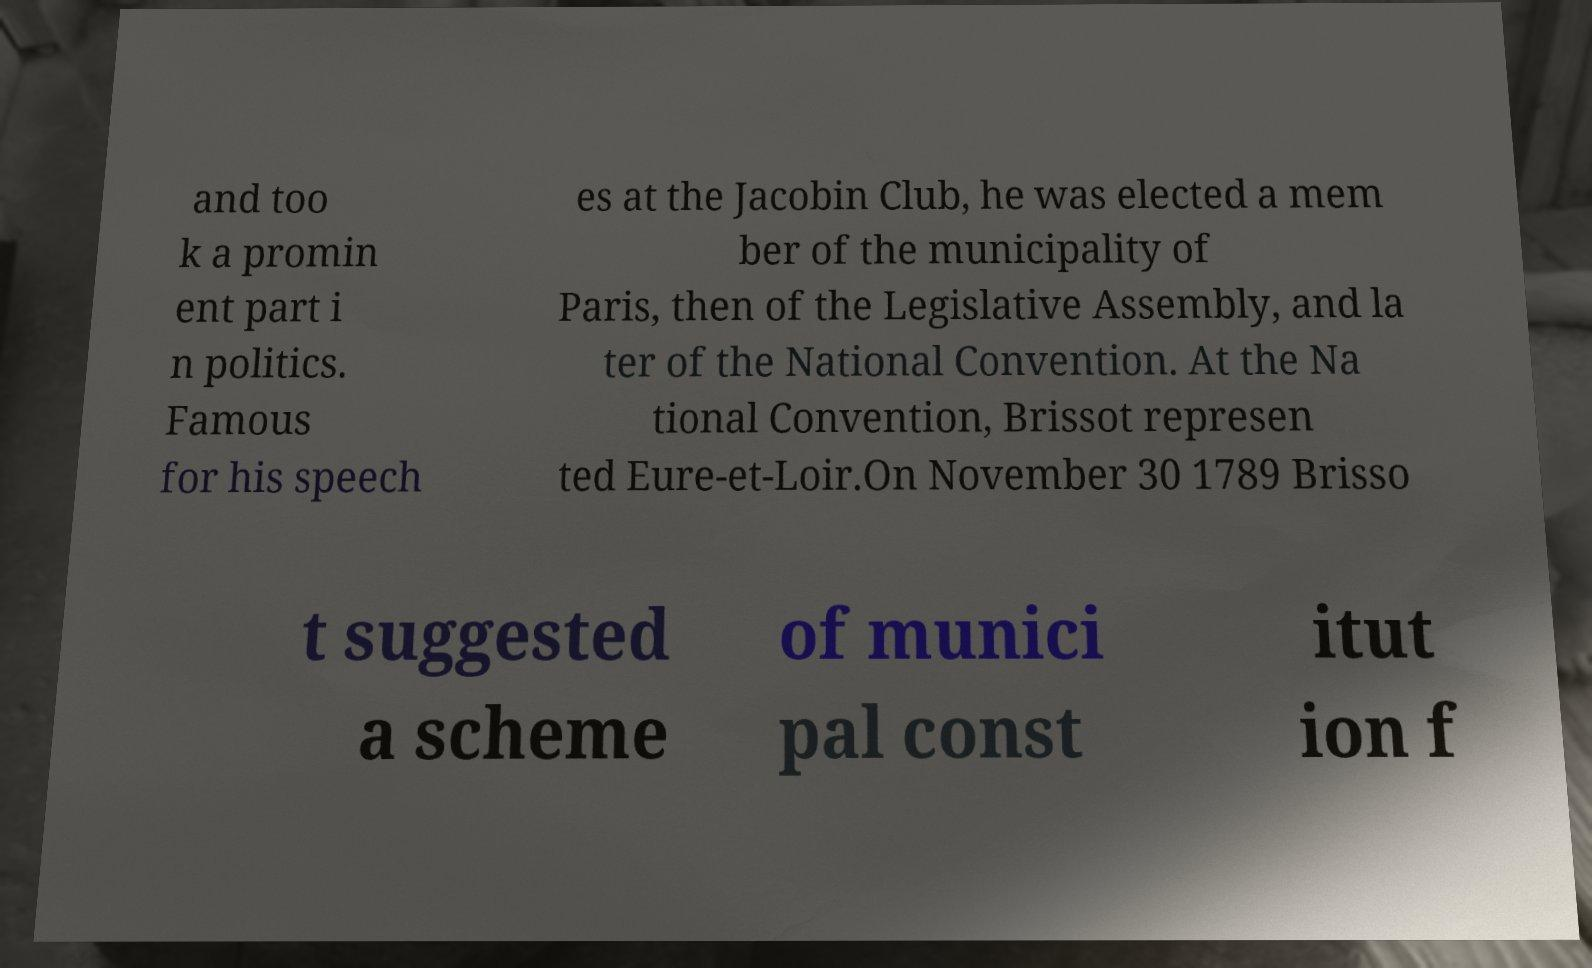Please read and relay the text visible in this image. What does it say? and too k a promin ent part i n politics. Famous for his speech es at the Jacobin Club, he was elected a mem ber of the municipality of Paris, then of the Legislative Assembly, and la ter of the National Convention. At the Na tional Convention, Brissot represen ted Eure-et-Loir.On November 30 1789 Brisso t suggested a scheme of munici pal const itut ion f 